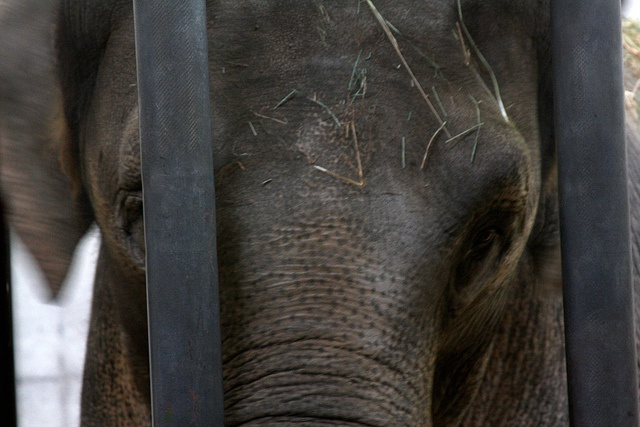Describe the objects in this image and their specific colors. I can see a elephant in black and gray tones in this image. 